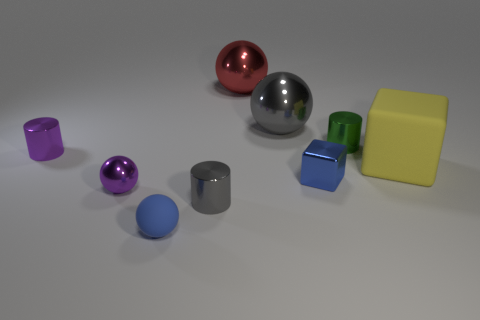Is there a tiny purple shiny thing?
Your answer should be compact. Yes. There is a gray metal object behind the small cylinder on the right side of the gray shiny thing behind the tiny green object; what is its size?
Provide a short and direct response. Large. What shape is the red object that is the same size as the yellow cube?
Give a very brief answer. Sphere. Are there any other things that have the same material as the small gray thing?
Your response must be concise. Yes. How many objects are small objects that are to the right of the tiny blue rubber ball or yellow matte spheres?
Offer a very short reply. 3. There is a cylinder that is right of the blue thing on the right side of the big gray shiny object; is there a small sphere that is on the right side of it?
Keep it short and to the point. No. What number of big objects are there?
Your answer should be compact. 3. What number of things are either small blue things that are in front of the gray metal cylinder or small shiny cylinders that are on the left side of the tiny green metal cylinder?
Provide a succinct answer. 3. Does the purple metallic object that is behind the purple ball have the same size as the large rubber object?
Offer a very short reply. No. The yellow thing that is the same shape as the small blue metal object is what size?
Provide a succinct answer. Large. 